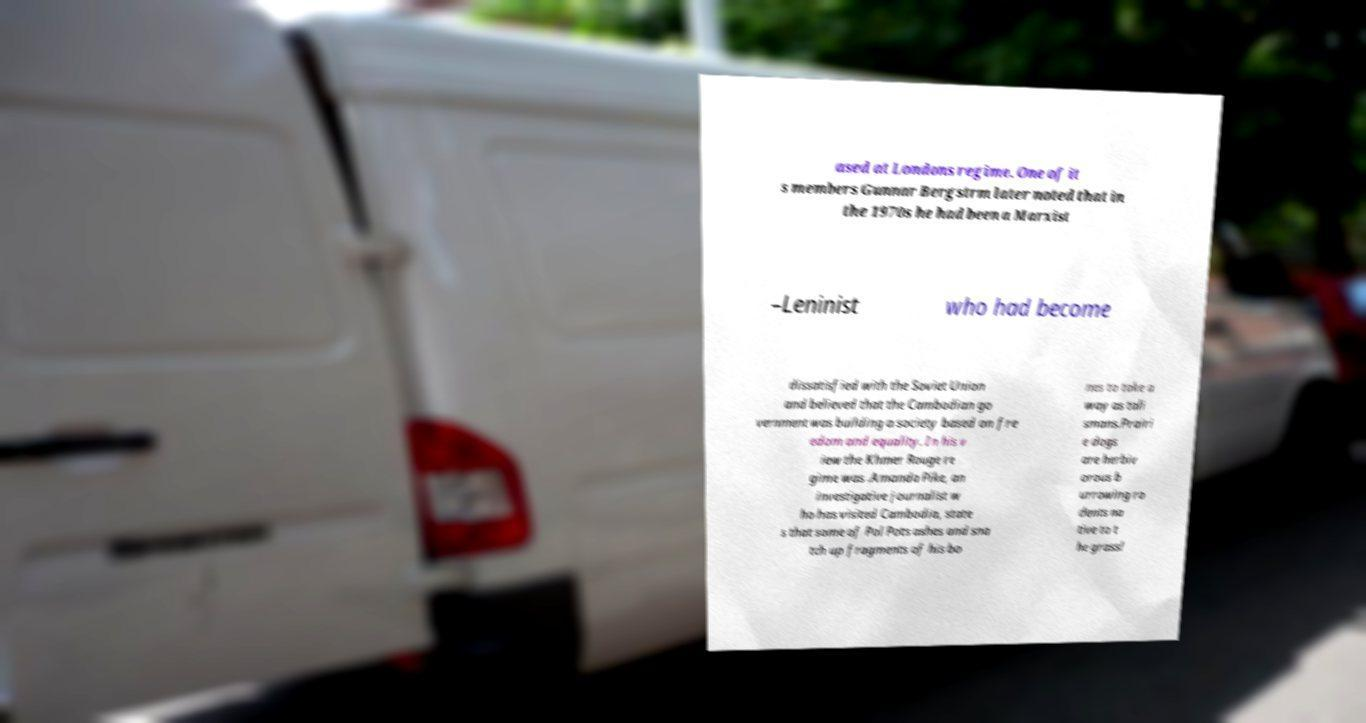I need the written content from this picture converted into text. Can you do that? ased at Londons regime. One of it s members Gunnar Bergstrm later noted that in the 1970s he had been a Marxist –Leninist who had become dissatisfied with the Soviet Union and believed that the Cambodian go vernment was building a society based on fre edom and equality. In his v iew the Khmer Rouge re gime was .Amanda Pike, an investigative journalist w ho has visited Cambodia, state s that some of Pol Pots ashes and sna tch up fragments of his bo nes to take a way as tali smans.Prairi e dogs are herbiv orous b urrowing ro dents na tive to t he grassl 